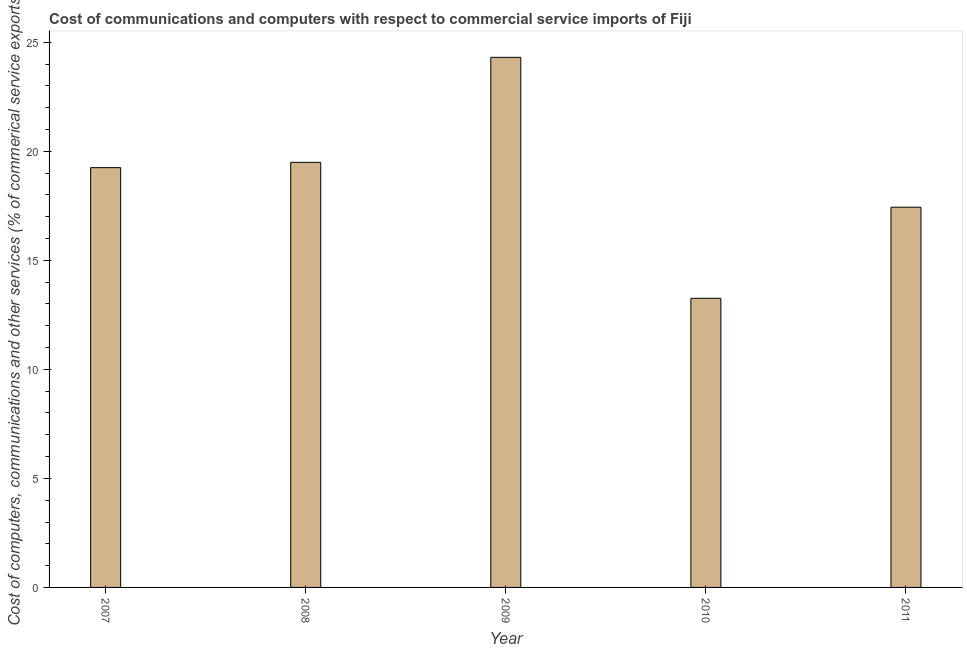Does the graph contain grids?
Give a very brief answer. No. What is the title of the graph?
Offer a very short reply. Cost of communications and computers with respect to commercial service imports of Fiji. What is the label or title of the X-axis?
Your answer should be very brief. Year. What is the label or title of the Y-axis?
Keep it short and to the point. Cost of computers, communications and other services (% of commerical service exports). What is the  computer and other services in 2007?
Offer a very short reply. 19.25. Across all years, what is the maximum cost of communications?
Your answer should be compact. 24.31. Across all years, what is the minimum  computer and other services?
Your response must be concise. 13.26. In which year was the cost of communications maximum?
Give a very brief answer. 2009. What is the sum of the  computer and other services?
Provide a short and direct response. 93.74. What is the difference between the  computer and other services in 2008 and 2009?
Provide a succinct answer. -4.82. What is the average cost of communications per year?
Offer a terse response. 18.75. What is the median  computer and other services?
Give a very brief answer. 19.25. In how many years, is the  computer and other services greater than 20 %?
Ensure brevity in your answer.  1. Do a majority of the years between 2008 and 2009 (inclusive) have cost of communications greater than 23 %?
Keep it short and to the point. No. What is the ratio of the cost of communications in 2007 to that in 2009?
Your answer should be compact. 0.79. Is the cost of communications in 2009 less than that in 2011?
Your answer should be very brief. No. Is the difference between the  computer and other services in 2010 and 2011 greater than the difference between any two years?
Your answer should be very brief. No. What is the difference between the highest and the second highest cost of communications?
Make the answer very short. 4.82. Is the sum of the  computer and other services in 2010 and 2011 greater than the maximum  computer and other services across all years?
Give a very brief answer. Yes. What is the difference between the highest and the lowest cost of communications?
Give a very brief answer. 11.05. Are all the bars in the graph horizontal?
Your response must be concise. No. What is the Cost of computers, communications and other services (% of commerical service exports) in 2007?
Your answer should be compact. 19.25. What is the Cost of computers, communications and other services (% of commerical service exports) in 2008?
Your response must be concise. 19.49. What is the Cost of computers, communications and other services (% of commerical service exports) of 2009?
Make the answer very short. 24.31. What is the Cost of computers, communications and other services (% of commerical service exports) of 2010?
Offer a terse response. 13.26. What is the Cost of computers, communications and other services (% of commerical service exports) of 2011?
Offer a very short reply. 17.43. What is the difference between the Cost of computers, communications and other services (% of commerical service exports) in 2007 and 2008?
Make the answer very short. -0.24. What is the difference between the Cost of computers, communications and other services (% of commerical service exports) in 2007 and 2009?
Make the answer very short. -5.06. What is the difference between the Cost of computers, communications and other services (% of commerical service exports) in 2007 and 2010?
Keep it short and to the point. 5.99. What is the difference between the Cost of computers, communications and other services (% of commerical service exports) in 2007 and 2011?
Provide a short and direct response. 1.81. What is the difference between the Cost of computers, communications and other services (% of commerical service exports) in 2008 and 2009?
Make the answer very short. -4.82. What is the difference between the Cost of computers, communications and other services (% of commerical service exports) in 2008 and 2010?
Make the answer very short. 6.23. What is the difference between the Cost of computers, communications and other services (% of commerical service exports) in 2008 and 2011?
Provide a short and direct response. 2.06. What is the difference between the Cost of computers, communications and other services (% of commerical service exports) in 2009 and 2010?
Keep it short and to the point. 11.05. What is the difference between the Cost of computers, communications and other services (% of commerical service exports) in 2009 and 2011?
Give a very brief answer. 6.87. What is the difference between the Cost of computers, communications and other services (% of commerical service exports) in 2010 and 2011?
Your answer should be very brief. -4.18. What is the ratio of the Cost of computers, communications and other services (% of commerical service exports) in 2007 to that in 2009?
Make the answer very short. 0.79. What is the ratio of the Cost of computers, communications and other services (% of commerical service exports) in 2007 to that in 2010?
Offer a terse response. 1.45. What is the ratio of the Cost of computers, communications and other services (% of commerical service exports) in 2007 to that in 2011?
Provide a succinct answer. 1.1. What is the ratio of the Cost of computers, communications and other services (% of commerical service exports) in 2008 to that in 2009?
Offer a terse response. 0.8. What is the ratio of the Cost of computers, communications and other services (% of commerical service exports) in 2008 to that in 2010?
Offer a terse response. 1.47. What is the ratio of the Cost of computers, communications and other services (% of commerical service exports) in 2008 to that in 2011?
Offer a very short reply. 1.12. What is the ratio of the Cost of computers, communications and other services (% of commerical service exports) in 2009 to that in 2010?
Ensure brevity in your answer.  1.83. What is the ratio of the Cost of computers, communications and other services (% of commerical service exports) in 2009 to that in 2011?
Offer a terse response. 1.39. What is the ratio of the Cost of computers, communications and other services (% of commerical service exports) in 2010 to that in 2011?
Your answer should be very brief. 0.76. 